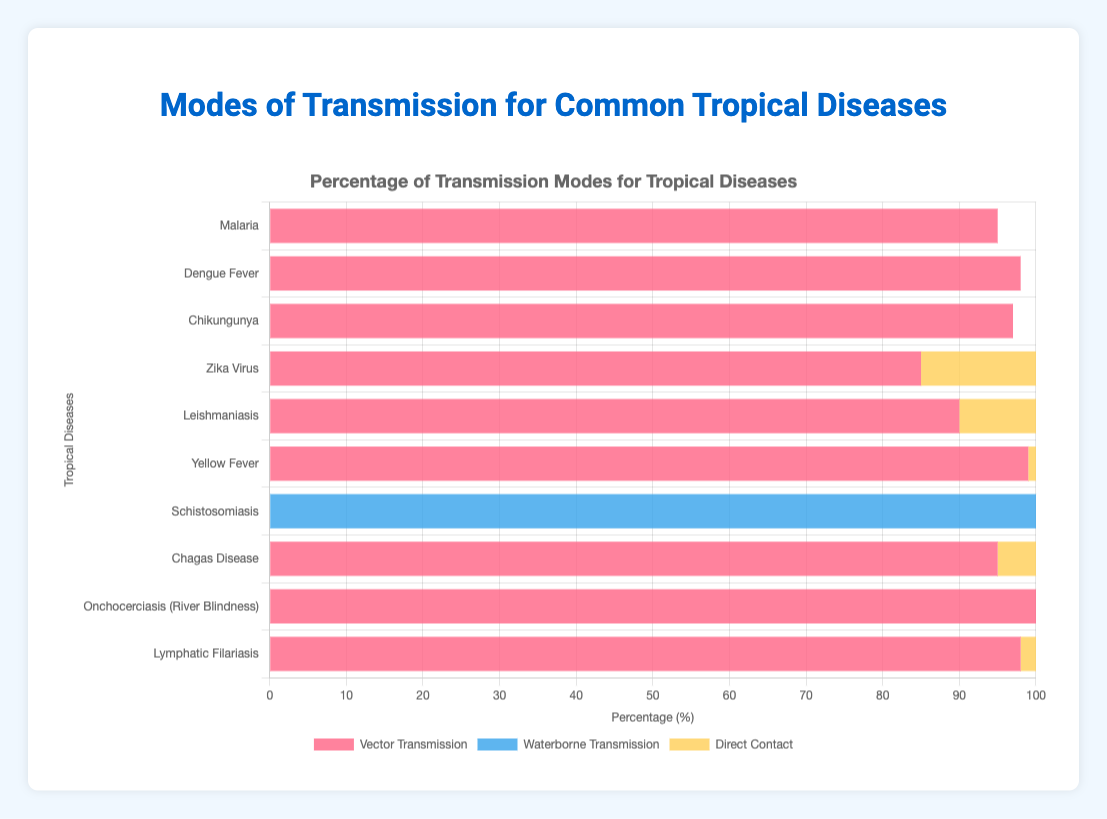Which disease has the highest percentage of direct contact transmission? Yellow Fever has the highest direct contact transmission at 1%. By examining the corresponding light yellow bar, it is evident it represents 1% for Yellow Fever.
Answer: Yellow Fever What disease is associated only with waterborne transmission? Schistosomiasis is solely transmitted by waterborne means. Examining the blue bar next to Schistosomiasis, it indicates 100% waterborne transmission with no other percentages shown.
Answer: Schistosomiasis Compare the vector transmission rates of Malaria and Dengue Fever. Which has a higher rate? Dengue Fever has a higher rate of vector transmission at 98% compared to Malaria's 95%. By comparing the lengths of the red bars next to each disease label, Dengue Fever’s bar is slightly longer.
Answer: Dengue Fever What is the combined percentage for direct contact and waterborne transmission for Zika Virus? Zika Virus has 15% for direct contact and 0% for waterborne transmission. Summing these values gives 15 + 0 = 15%.
Answer: 15% Which diseases have exactly 0% direct contact transmission? Malaria, Dengue Fever, Chikungunya, Schistosomiasis, and Onchocerciasis have 0% direct contact transmission. Observing the light yellow bars shows these diseases have no such bars.
Answer: Malaria, Dengue Fever, Chikungunya, Schistosomiasis, Onchocerciasis Does Chikungunya have a higher or lower vector transmission rate than Leishmaniasis? Chikungunya has a higher vector transmission rate of 97% compared to Leishmaniasis's 90%. This is observable by comparing the lengths of the red bars, with Chikungunya's being longer.
Answer: Higher Which mode of transmission is exclusively used by Onchocerciasis? Onchocerciasis relies entirely on vector transmission. This is indicated by the 100% value for vector transmission and 0% for other modes, shown by the red bar next to it.
Answer: Vector Transmission How many diseases have their vector transmission rate below 90%? Only Zika Virus has a vector transmission rate below 90%, which is at 85%. Examining the red bars visually confirms that all other diseases have vector transmission rates at or above 90%.
Answer: 1 What is the average vector transmission rate for Malaria, Dengue Fever, and Yellow Fever? The vector transmission rates are Malaria (95%), Dengue Fever (98%), and Yellow Fever (99%). Their average is calculated as (95 + 98 + 99) / 3 = 97.33%.
Answer: 97.33% Compare the sum of direct contact transmission rates between Leishmaniasis and Chagas Disease. Which is higher? Leishmaniasis has 10% and Chagas Disease has 5% direct contact transmission. Summing these gives Leishmaniasis 10% and Chagas Disease 5%. 10 > 5, so Leishmaniasis is higher.
Answer: Leishmaniasis 